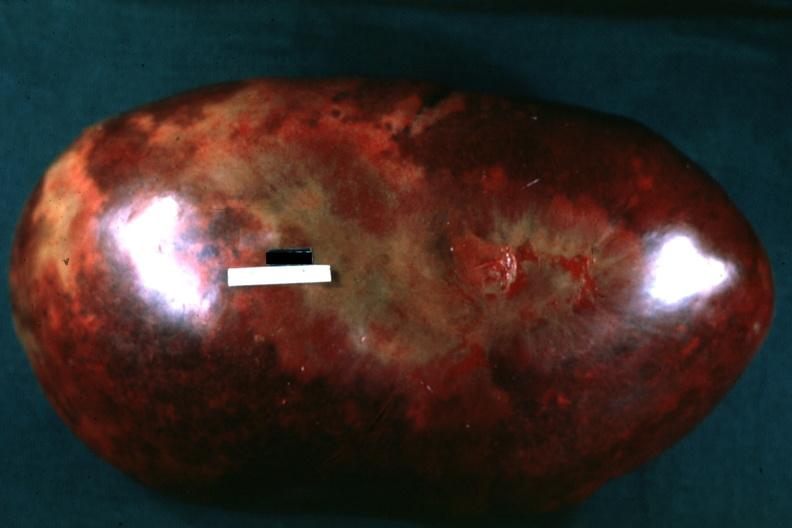where is this part in?
Answer the question using a single word or phrase. Spleen 